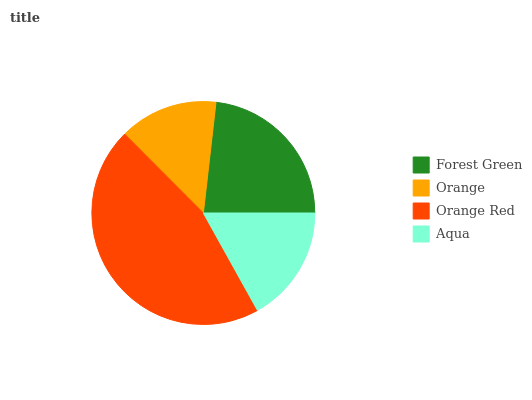Is Orange the minimum?
Answer yes or no. Yes. Is Orange Red the maximum?
Answer yes or no. Yes. Is Orange Red the minimum?
Answer yes or no. No. Is Orange the maximum?
Answer yes or no. No. Is Orange Red greater than Orange?
Answer yes or no. Yes. Is Orange less than Orange Red?
Answer yes or no. Yes. Is Orange greater than Orange Red?
Answer yes or no. No. Is Orange Red less than Orange?
Answer yes or no. No. Is Forest Green the high median?
Answer yes or no. Yes. Is Aqua the low median?
Answer yes or no. Yes. Is Aqua the high median?
Answer yes or no. No. Is Forest Green the low median?
Answer yes or no. No. 